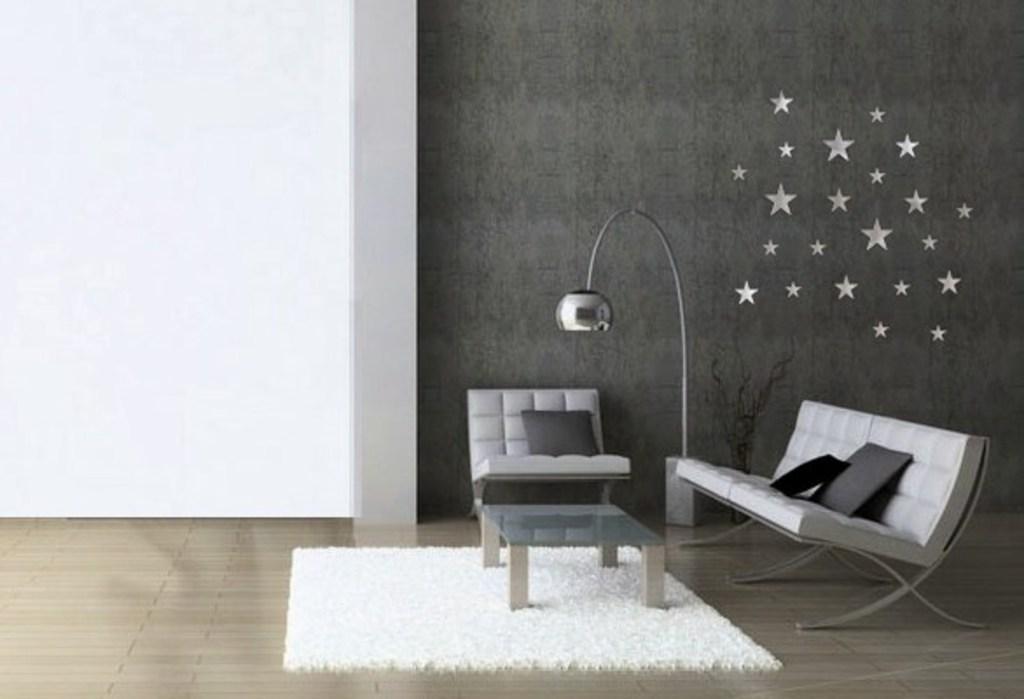How would you summarize this image in a sentence or two? In the image there is a chair and a sofa and there is a lamp and on the wall there are stars shaped decoration. 